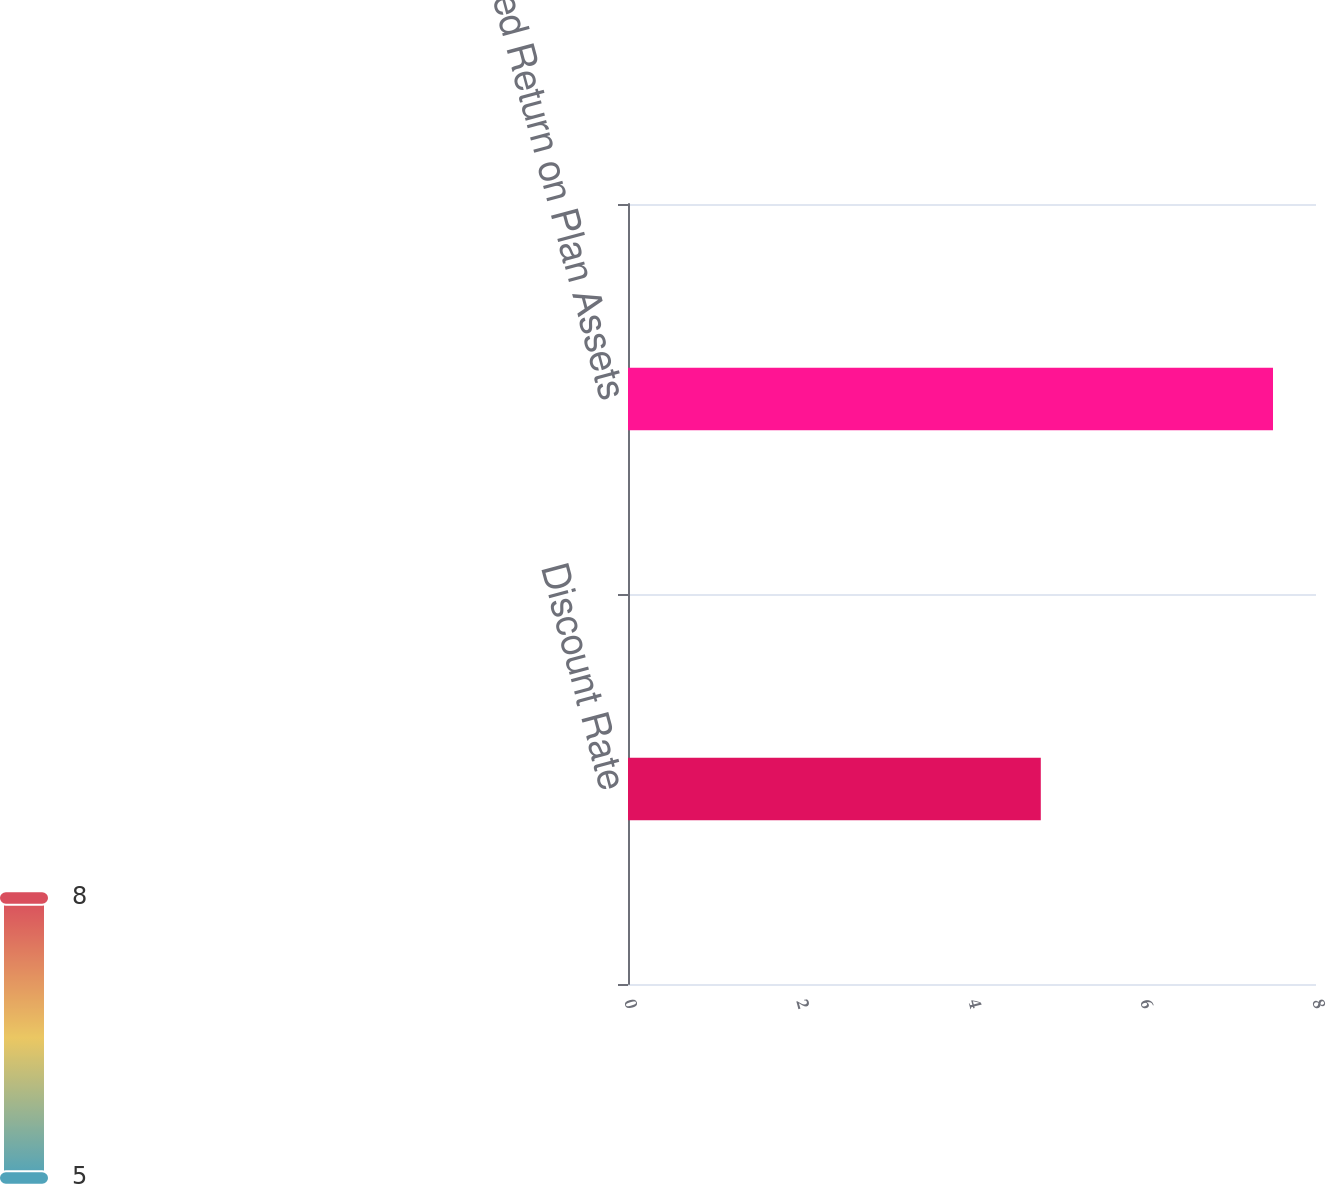Convert chart to OTSL. <chart><loc_0><loc_0><loc_500><loc_500><bar_chart><fcel>Discount Rate<fcel>Expected Return on Plan Assets<nl><fcel>4.8<fcel>7.5<nl></chart> 